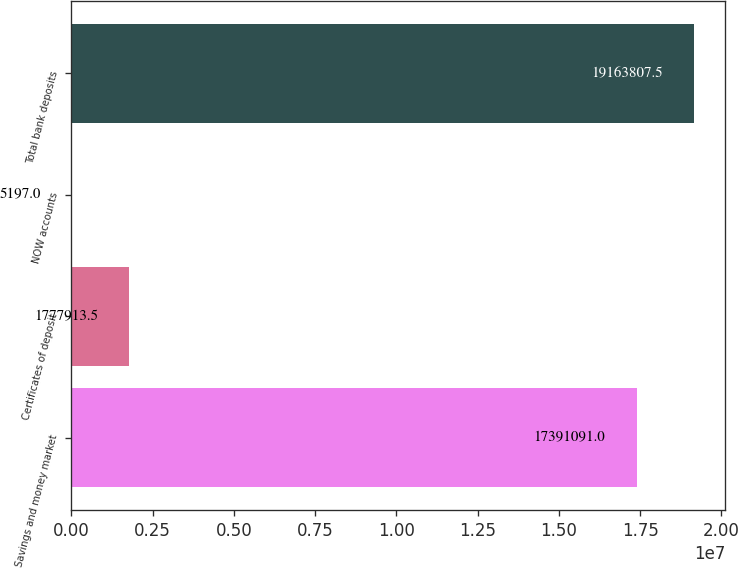<chart> <loc_0><loc_0><loc_500><loc_500><bar_chart><fcel>Savings and money market<fcel>Certificates of deposit<fcel>NOW accounts<fcel>Total bank deposits<nl><fcel>1.73911e+07<fcel>1.77791e+06<fcel>5197<fcel>1.91638e+07<nl></chart> 